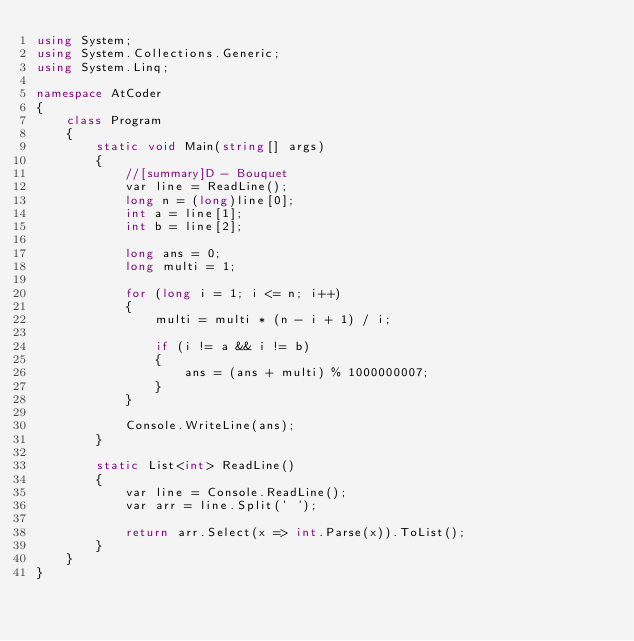<code> <loc_0><loc_0><loc_500><loc_500><_C#_>using System;
using System.Collections.Generic;
using System.Linq;

namespace AtCoder
{
    class Program
    {
        static void Main(string[] args)
        {
            //[summary]D - Bouquet
            var line = ReadLine();
            long n = (long)line[0];
            int a = line[1];
            int b = line[2];

            long ans = 0;
            long multi = 1;

            for (long i = 1; i <= n; i++)
            {
                multi = multi * (n - i + 1) / i;

                if (i != a && i != b)
                {
                    ans = (ans + multi) % 1000000007;
                }                
            }

            Console.WriteLine(ans);
        }

        static List<int> ReadLine()
        {
            var line = Console.ReadLine();
            var arr = line.Split(' ');

            return arr.Select(x => int.Parse(x)).ToList();
        }
    }
}</code> 